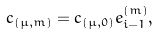Convert formula to latex. <formula><loc_0><loc_0><loc_500><loc_500>c _ { ( \mu , m ) } = { c } _ { ( \mu , 0 ) } e _ { i - 1 } ^ { ( m ) } ,</formula> 